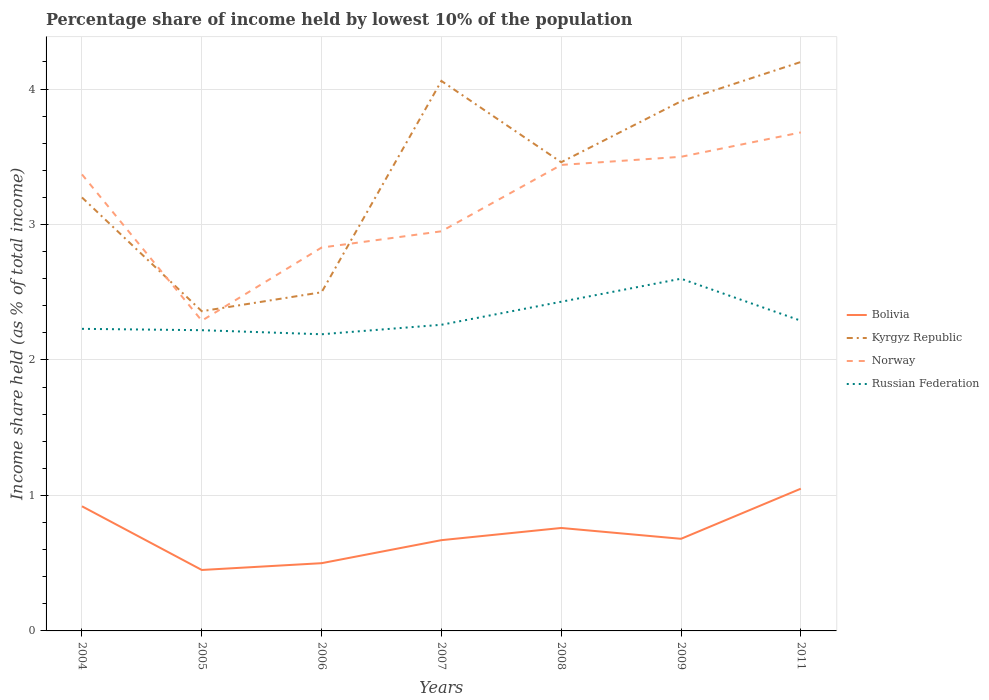How many different coloured lines are there?
Ensure brevity in your answer.  4. Does the line corresponding to Kyrgyz Republic intersect with the line corresponding to Bolivia?
Give a very brief answer. No. Is the number of lines equal to the number of legend labels?
Your response must be concise. Yes. Across all years, what is the maximum percentage share of income held by lowest 10% of the population in Norway?
Ensure brevity in your answer.  2.29. What is the total percentage share of income held by lowest 10% of the population in Norway in the graph?
Your answer should be very brief. -0.73. What is the difference between the highest and the second highest percentage share of income held by lowest 10% of the population in Norway?
Provide a short and direct response. 1.39. Is the percentage share of income held by lowest 10% of the population in Russian Federation strictly greater than the percentage share of income held by lowest 10% of the population in Kyrgyz Republic over the years?
Offer a terse response. Yes. How many lines are there?
Offer a terse response. 4. How many years are there in the graph?
Offer a very short reply. 7. Does the graph contain grids?
Offer a very short reply. Yes. How many legend labels are there?
Provide a succinct answer. 4. What is the title of the graph?
Offer a very short reply. Percentage share of income held by lowest 10% of the population. Does "Egypt, Arab Rep." appear as one of the legend labels in the graph?
Provide a short and direct response. No. What is the label or title of the Y-axis?
Offer a terse response. Income share held (as % of total income). What is the Income share held (as % of total income) of Bolivia in 2004?
Your response must be concise. 0.92. What is the Income share held (as % of total income) in Kyrgyz Republic in 2004?
Keep it short and to the point. 3.2. What is the Income share held (as % of total income) of Norway in 2004?
Provide a short and direct response. 3.37. What is the Income share held (as % of total income) in Russian Federation in 2004?
Provide a succinct answer. 2.23. What is the Income share held (as % of total income) of Bolivia in 2005?
Keep it short and to the point. 0.45. What is the Income share held (as % of total income) in Kyrgyz Republic in 2005?
Your answer should be very brief. 2.36. What is the Income share held (as % of total income) of Norway in 2005?
Keep it short and to the point. 2.29. What is the Income share held (as % of total income) of Russian Federation in 2005?
Your answer should be very brief. 2.22. What is the Income share held (as % of total income) of Norway in 2006?
Ensure brevity in your answer.  2.83. What is the Income share held (as % of total income) in Russian Federation in 2006?
Your response must be concise. 2.19. What is the Income share held (as % of total income) of Bolivia in 2007?
Your answer should be very brief. 0.67. What is the Income share held (as % of total income) of Kyrgyz Republic in 2007?
Give a very brief answer. 4.06. What is the Income share held (as % of total income) in Norway in 2007?
Give a very brief answer. 2.95. What is the Income share held (as % of total income) in Russian Federation in 2007?
Offer a terse response. 2.26. What is the Income share held (as % of total income) of Bolivia in 2008?
Provide a succinct answer. 0.76. What is the Income share held (as % of total income) in Kyrgyz Republic in 2008?
Offer a terse response. 3.46. What is the Income share held (as % of total income) of Norway in 2008?
Make the answer very short. 3.44. What is the Income share held (as % of total income) of Russian Federation in 2008?
Make the answer very short. 2.43. What is the Income share held (as % of total income) of Bolivia in 2009?
Provide a short and direct response. 0.68. What is the Income share held (as % of total income) in Kyrgyz Republic in 2009?
Offer a terse response. 3.91. What is the Income share held (as % of total income) of Norway in 2009?
Make the answer very short. 3.5. What is the Income share held (as % of total income) in Bolivia in 2011?
Provide a succinct answer. 1.05. What is the Income share held (as % of total income) in Norway in 2011?
Provide a short and direct response. 3.68. What is the Income share held (as % of total income) of Russian Federation in 2011?
Keep it short and to the point. 2.29. Across all years, what is the maximum Income share held (as % of total income) in Bolivia?
Offer a terse response. 1.05. Across all years, what is the maximum Income share held (as % of total income) in Kyrgyz Republic?
Offer a very short reply. 4.2. Across all years, what is the maximum Income share held (as % of total income) of Norway?
Your answer should be compact. 3.68. Across all years, what is the minimum Income share held (as % of total income) of Bolivia?
Offer a terse response. 0.45. Across all years, what is the minimum Income share held (as % of total income) of Kyrgyz Republic?
Ensure brevity in your answer.  2.36. Across all years, what is the minimum Income share held (as % of total income) in Norway?
Give a very brief answer. 2.29. Across all years, what is the minimum Income share held (as % of total income) of Russian Federation?
Provide a succinct answer. 2.19. What is the total Income share held (as % of total income) in Bolivia in the graph?
Your answer should be compact. 5.03. What is the total Income share held (as % of total income) in Kyrgyz Republic in the graph?
Your answer should be very brief. 23.69. What is the total Income share held (as % of total income) in Norway in the graph?
Provide a succinct answer. 22.06. What is the total Income share held (as % of total income) in Russian Federation in the graph?
Offer a terse response. 16.22. What is the difference between the Income share held (as % of total income) of Bolivia in 2004 and that in 2005?
Provide a short and direct response. 0.47. What is the difference between the Income share held (as % of total income) in Kyrgyz Republic in 2004 and that in 2005?
Provide a short and direct response. 0.84. What is the difference between the Income share held (as % of total income) of Russian Federation in 2004 and that in 2005?
Provide a short and direct response. 0.01. What is the difference between the Income share held (as % of total income) in Bolivia in 2004 and that in 2006?
Your answer should be compact. 0.42. What is the difference between the Income share held (as % of total income) in Norway in 2004 and that in 2006?
Offer a terse response. 0.54. What is the difference between the Income share held (as % of total income) in Russian Federation in 2004 and that in 2006?
Offer a very short reply. 0.04. What is the difference between the Income share held (as % of total income) of Bolivia in 2004 and that in 2007?
Offer a very short reply. 0.25. What is the difference between the Income share held (as % of total income) of Kyrgyz Republic in 2004 and that in 2007?
Make the answer very short. -0.86. What is the difference between the Income share held (as % of total income) in Norway in 2004 and that in 2007?
Give a very brief answer. 0.42. What is the difference between the Income share held (as % of total income) of Russian Federation in 2004 and that in 2007?
Make the answer very short. -0.03. What is the difference between the Income share held (as % of total income) of Bolivia in 2004 and that in 2008?
Make the answer very short. 0.16. What is the difference between the Income share held (as % of total income) of Kyrgyz Republic in 2004 and that in 2008?
Your answer should be compact. -0.26. What is the difference between the Income share held (as % of total income) in Norway in 2004 and that in 2008?
Your response must be concise. -0.07. What is the difference between the Income share held (as % of total income) in Russian Federation in 2004 and that in 2008?
Provide a succinct answer. -0.2. What is the difference between the Income share held (as % of total income) in Bolivia in 2004 and that in 2009?
Keep it short and to the point. 0.24. What is the difference between the Income share held (as % of total income) of Kyrgyz Republic in 2004 and that in 2009?
Your response must be concise. -0.71. What is the difference between the Income share held (as % of total income) of Norway in 2004 and that in 2009?
Make the answer very short. -0.13. What is the difference between the Income share held (as % of total income) of Russian Federation in 2004 and that in 2009?
Offer a terse response. -0.37. What is the difference between the Income share held (as % of total income) in Bolivia in 2004 and that in 2011?
Make the answer very short. -0.13. What is the difference between the Income share held (as % of total income) of Norway in 2004 and that in 2011?
Your answer should be compact. -0.31. What is the difference between the Income share held (as % of total income) in Russian Federation in 2004 and that in 2011?
Your response must be concise. -0.06. What is the difference between the Income share held (as % of total income) in Bolivia in 2005 and that in 2006?
Ensure brevity in your answer.  -0.05. What is the difference between the Income share held (as % of total income) in Kyrgyz Republic in 2005 and that in 2006?
Offer a terse response. -0.14. What is the difference between the Income share held (as % of total income) in Norway in 2005 and that in 2006?
Give a very brief answer. -0.54. What is the difference between the Income share held (as % of total income) in Russian Federation in 2005 and that in 2006?
Give a very brief answer. 0.03. What is the difference between the Income share held (as % of total income) in Bolivia in 2005 and that in 2007?
Keep it short and to the point. -0.22. What is the difference between the Income share held (as % of total income) in Kyrgyz Republic in 2005 and that in 2007?
Ensure brevity in your answer.  -1.7. What is the difference between the Income share held (as % of total income) of Norway in 2005 and that in 2007?
Ensure brevity in your answer.  -0.66. What is the difference between the Income share held (as % of total income) in Russian Federation in 2005 and that in 2007?
Offer a terse response. -0.04. What is the difference between the Income share held (as % of total income) in Bolivia in 2005 and that in 2008?
Your response must be concise. -0.31. What is the difference between the Income share held (as % of total income) of Norway in 2005 and that in 2008?
Your answer should be compact. -1.15. What is the difference between the Income share held (as % of total income) in Russian Federation in 2005 and that in 2008?
Give a very brief answer. -0.21. What is the difference between the Income share held (as % of total income) of Bolivia in 2005 and that in 2009?
Give a very brief answer. -0.23. What is the difference between the Income share held (as % of total income) in Kyrgyz Republic in 2005 and that in 2009?
Make the answer very short. -1.55. What is the difference between the Income share held (as % of total income) of Norway in 2005 and that in 2009?
Provide a succinct answer. -1.21. What is the difference between the Income share held (as % of total income) in Russian Federation in 2005 and that in 2009?
Ensure brevity in your answer.  -0.38. What is the difference between the Income share held (as % of total income) of Kyrgyz Republic in 2005 and that in 2011?
Make the answer very short. -1.84. What is the difference between the Income share held (as % of total income) of Norway in 2005 and that in 2011?
Provide a short and direct response. -1.39. What is the difference between the Income share held (as % of total income) in Russian Federation in 2005 and that in 2011?
Your response must be concise. -0.07. What is the difference between the Income share held (as % of total income) in Bolivia in 2006 and that in 2007?
Provide a succinct answer. -0.17. What is the difference between the Income share held (as % of total income) in Kyrgyz Republic in 2006 and that in 2007?
Provide a short and direct response. -1.56. What is the difference between the Income share held (as % of total income) of Norway in 2006 and that in 2007?
Give a very brief answer. -0.12. What is the difference between the Income share held (as % of total income) of Russian Federation in 2006 and that in 2007?
Keep it short and to the point. -0.07. What is the difference between the Income share held (as % of total income) of Bolivia in 2006 and that in 2008?
Give a very brief answer. -0.26. What is the difference between the Income share held (as % of total income) in Kyrgyz Republic in 2006 and that in 2008?
Your answer should be very brief. -0.96. What is the difference between the Income share held (as % of total income) in Norway in 2006 and that in 2008?
Keep it short and to the point. -0.61. What is the difference between the Income share held (as % of total income) in Russian Federation in 2006 and that in 2008?
Your answer should be very brief. -0.24. What is the difference between the Income share held (as % of total income) of Bolivia in 2006 and that in 2009?
Ensure brevity in your answer.  -0.18. What is the difference between the Income share held (as % of total income) of Kyrgyz Republic in 2006 and that in 2009?
Your response must be concise. -1.41. What is the difference between the Income share held (as % of total income) in Norway in 2006 and that in 2009?
Ensure brevity in your answer.  -0.67. What is the difference between the Income share held (as % of total income) in Russian Federation in 2006 and that in 2009?
Give a very brief answer. -0.41. What is the difference between the Income share held (as % of total income) in Bolivia in 2006 and that in 2011?
Keep it short and to the point. -0.55. What is the difference between the Income share held (as % of total income) in Kyrgyz Republic in 2006 and that in 2011?
Provide a short and direct response. -1.7. What is the difference between the Income share held (as % of total income) of Norway in 2006 and that in 2011?
Offer a terse response. -0.85. What is the difference between the Income share held (as % of total income) in Russian Federation in 2006 and that in 2011?
Provide a short and direct response. -0.1. What is the difference between the Income share held (as % of total income) of Bolivia in 2007 and that in 2008?
Make the answer very short. -0.09. What is the difference between the Income share held (as % of total income) in Norway in 2007 and that in 2008?
Provide a short and direct response. -0.49. What is the difference between the Income share held (as % of total income) of Russian Federation in 2007 and that in 2008?
Ensure brevity in your answer.  -0.17. What is the difference between the Income share held (as % of total income) of Bolivia in 2007 and that in 2009?
Your response must be concise. -0.01. What is the difference between the Income share held (as % of total income) in Kyrgyz Republic in 2007 and that in 2009?
Provide a succinct answer. 0.15. What is the difference between the Income share held (as % of total income) of Norway in 2007 and that in 2009?
Offer a terse response. -0.55. What is the difference between the Income share held (as % of total income) of Russian Federation in 2007 and that in 2009?
Provide a succinct answer. -0.34. What is the difference between the Income share held (as % of total income) in Bolivia in 2007 and that in 2011?
Your answer should be compact. -0.38. What is the difference between the Income share held (as % of total income) of Kyrgyz Republic in 2007 and that in 2011?
Provide a succinct answer. -0.14. What is the difference between the Income share held (as % of total income) of Norway in 2007 and that in 2011?
Your response must be concise. -0.73. What is the difference between the Income share held (as % of total income) in Russian Federation in 2007 and that in 2011?
Offer a terse response. -0.03. What is the difference between the Income share held (as % of total income) in Bolivia in 2008 and that in 2009?
Your answer should be very brief. 0.08. What is the difference between the Income share held (as % of total income) in Kyrgyz Republic in 2008 and that in 2009?
Provide a succinct answer. -0.45. What is the difference between the Income share held (as % of total income) of Norway in 2008 and that in 2009?
Keep it short and to the point. -0.06. What is the difference between the Income share held (as % of total income) of Russian Federation in 2008 and that in 2009?
Offer a very short reply. -0.17. What is the difference between the Income share held (as % of total income) of Bolivia in 2008 and that in 2011?
Your answer should be very brief. -0.29. What is the difference between the Income share held (as % of total income) of Kyrgyz Republic in 2008 and that in 2011?
Your response must be concise. -0.74. What is the difference between the Income share held (as % of total income) of Norway in 2008 and that in 2011?
Your response must be concise. -0.24. What is the difference between the Income share held (as % of total income) of Russian Federation in 2008 and that in 2011?
Offer a terse response. 0.14. What is the difference between the Income share held (as % of total income) of Bolivia in 2009 and that in 2011?
Your answer should be compact. -0.37. What is the difference between the Income share held (as % of total income) of Kyrgyz Republic in 2009 and that in 2011?
Offer a very short reply. -0.29. What is the difference between the Income share held (as % of total income) in Norway in 2009 and that in 2011?
Offer a very short reply. -0.18. What is the difference between the Income share held (as % of total income) in Russian Federation in 2009 and that in 2011?
Give a very brief answer. 0.31. What is the difference between the Income share held (as % of total income) in Bolivia in 2004 and the Income share held (as % of total income) in Kyrgyz Republic in 2005?
Offer a very short reply. -1.44. What is the difference between the Income share held (as % of total income) of Bolivia in 2004 and the Income share held (as % of total income) of Norway in 2005?
Your response must be concise. -1.37. What is the difference between the Income share held (as % of total income) of Kyrgyz Republic in 2004 and the Income share held (as % of total income) of Norway in 2005?
Your response must be concise. 0.91. What is the difference between the Income share held (as % of total income) of Norway in 2004 and the Income share held (as % of total income) of Russian Federation in 2005?
Your answer should be compact. 1.15. What is the difference between the Income share held (as % of total income) of Bolivia in 2004 and the Income share held (as % of total income) of Kyrgyz Republic in 2006?
Provide a succinct answer. -1.58. What is the difference between the Income share held (as % of total income) in Bolivia in 2004 and the Income share held (as % of total income) in Norway in 2006?
Make the answer very short. -1.91. What is the difference between the Income share held (as % of total income) of Bolivia in 2004 and the Income share held (as % of total income) of Russian Federation in 2006?
Your response must be concise. -1.27. What is the difference between the Income share held (as % of total income) in Kyrgyz Republic in 2004 and the Income share held (as % of total income) in Norway in 2006?
Keep it short and to the point. 0.37. What is the difference between the Income share held (as % of total income) of Norway in 2004 and the Income share held (as % of total income) of Russian Federation in 2006?
Keep it short and to the point. 1.18. What is the difference between the Income share held (as % of total income) of Bolivia in 2004 and the Income share held (as % of total income) of Kyrgyz Republic in 2007?
Ensure brevity in your answer.  -3.14. What is the difference between the Income share held (as % of total income) of Bolivia in 2004 and the Income share held (as % of total income) of Norway in 2007?
Your answer should be very brief. -2.03. What is the difference between the Income share held (as % of total income) in Bolivia in 2004 and the Income share held (as % of total income) in Russian Federation in 2007?
Offer a very short reply. -1.34. What is the difference between the Income share held (as % of total income) in Kyrgyz Republic in 2004 and the Income share held (as % of total income) in Norway in 2007?
Your answer should be compact. 0.25. What is the difference between the Income share held (as % of total income) in Kyrgyz Republic in 2004 and the Income share held (as % of total income) in Russian Federation in 2007?
Your response must be concise. 0.94. What is the difference between the Income share held (as % of total income) of Norway in 2004 and the Income share held (as % of total income) of Russian Federation in 2007?
Offer a terse response. 1.11. What is the difference between the Income share held (as % of total income) of Bolivia in 2004 and the Income share held (as % of total income) of Kyrgyz Republic in 2008?
Offer a very short reply. -2.54. What is the difference between the Income share held (as % of total income) in Bolivia in 2004 and the Income share held (as % of total income) in Norway in 2008?
Give a very brief answer. -2.52. What is the difference between the Income share held (as % of total income) in Bolivia in 2004 and the Income share held (as % of total income) in Russian Federation in 2008?
Ensure brevity in your answer.  -1.51. What is the difference between the Income share held (as % of total income) of Kyrgyz Republic in 2004 and the Income share held (as % of total income) of Norway in 2008?
Keep it short and to the point. -0.24. What is the difference between the Income share held (as % of total income) in Kyrgyz Republic in 2004 and the Income share held (as % of total income) in Russian Federation in 2008?
Ensure brevity in your answer.  0.77. What is the difference between the Income share held (as % of total income) in Bolivia in 2004 and the Income share held (as % of total income) in Kyrgyz Republic in 2009?
Your answer should be compact. -2.99. What is the difference between the Income share held (as % of total income) in Bolivia in 2004 and the Income share held (as % of total income) in Norway in 2009?
Make the answer very short. -2.58. What is the difference between the Income share held (as % of total income) in Bolivia in 2004 and the Income share held (as % of total income) in Russian Federation in 2009?
Your response must be concise. -1.68. What is the difference between the Income share held (as % of total income) in Kyrgyz Republic in 2004 and the Income share held (as % of total income) in Norway in 2009?
Keep it short and to the point. -0.3. What is the difference between the Income share held (as % of total income) in Norway in 2004 and the Income share held (as % of total income) in Russian Federation in 2009?
Ensure brevity in your answer.  0.77. What is the difference between the Income share held (as % of total income) in Bolivia in 2004 and the Income share held (as % of total income) in Kyrgyz Republic in 2011?
Keep it short and to the point. -3.28. What is the difference between the Income share held (as % of total income) of Bolivia in 2004 and the Income share held (as % of total income) of Norway in 2011?
Your answer should be compact. -2.76. What is the difference between the Income share held (as % of total income) of Bolivia in 2004 and the Income share held (as % of total income) of Russian Federation in 2011?
Your response must be concise. -1.37. What is the difference between the Income share held (as % of total income) of Kyrgyz Republic in 2004 and the Income share held (as % of total income) of Norway in 2011?
Your answer should be very brief. -0.48. What is the difference between the Income share held (as % of total income) in Kyrgyz Republic in 2004 and the Income share held (as % of total income) in Russian Federation in 2011?
Provide a short and direct response. 0.91. What is the difference between the Income share held (as % of total income) in Bolivia in 2005 and the Income share held (as % of total income) in Kyrgyz Republic in 2006?
Make the answer very short. -2.05. What is the difference between the Income share held (as % of total income) of Bolivia in 2005 and the Income share held (as % of total income) of Norway in 2006?
Provide a short and direct response. -2.38. What is the difference between the Income share held (as % of total income) in Bolivia in 2005 and the Income share held (as % of total income) in Russian Federation in 2006?
Provide a short and direct response. -1.74. What is the difference between the Income share held (as % of total income) in Kyrgyz Republic in 2005 and the Income share held (as % of total income) in Norway in 2006?
Provide a succinct answer. -0.47. What is the difference between the Income share held (as % of total income) in Kyrgyz Republic in 2005 and the Income share held (as % of total income) in Russian Federation in 2006?
Give a very brief answer. 0.17. What is the difference between the Income share held (as % of total income) of Norway in 2005 and the Income share held (as % of total income) of Russian Federation in 2006?
Provide a succinct answer. 0.1. What is the difference between the Income share held (as % of total income) in Bolivia in 2005 and the Income share held (as % of total income) in Kyrgyz Republic in 2007?
Give a very brief answer. -3.61. What is the difference between the Income share held (as % of total income) in Bolivia in 2005 and the Income share held (as % of total income) in Norway in 2007?
Ensure brevity in your answer.  -2.5. What is the difference between the Income share held (as % of total income) of Bolivia in 2005 and the Income share held (as % of total income) of Russian Federation in 2007?
Provide a short and direct response. -1.81. What is the difference between the Income share held (as % of total income) in Kyrgyz Republic in 2005 and the Income share held (as % of total income) in Norway in 2007?
Provide a short and direct response. -0.59. What is the difference between the Income share held (as % of total income) of Bolivia in 2005 and the Income share held (as % of total income) of Kyrgyz Republic in 2008?
Keep it short and to the point. -3.01. What is the difference between the Income share held (as % of total income) of Bolivia in 2005 and the Income share held (as % of total income) of Norway in 2008?
Make the answer very short. -2.99. What is the difference between the Income share held (as % of total income) of Bolivia in 2005 and the Income share held (as % of total income) of Russian Federation in 2008?
Your answer should be compact. -1.98. What is the difference between the Income share held (as % of total income) in Kyrgyz Republic in 2005 and the Income share held (as % of total income) in Norway in 2008?
Keep it short and to the point. -1.08. What is the difference between the Income share held (as % of total income) in Kyrgyz Republic in 2005 and the Income share held (as % of total income) in Russian Federation in 2008?
Give a very brief answer. -0.07. What is the difference between the Income share held (as % of total income) of Norway in 2005 and the Income share held (as % of total income) of Russian Federation in 2008?
Your answer should be compact. -0.14. What is the difference between the Income share held (as % of total income) of Bolivia in 2005 and the Income share held (as % of total income) of Kyrgyz Republic in 2009?
Provide a succinct answer. -3.46. What is the difference between the Income share held (as % of total income) in Bolivia in 2005 and the Income share held (as % of total income) in Norway in 2009?
Give a very brief answer. -3.05. What is the difference between the Income share held (as % of total income) in Bolivia in 2005 and the Income share held (as % of total income) in Russian Federation in 2009?
Your answer should be compact. -2.15. What is the difference between the Income share held (as % of total income) of Kyrgyz Republic in 2005 and the Income share held (as % of total income) of Norway in 2009?
Make the answer very short. -1.14. What is the difference between the Income share held (as % of total income) in Kyrgyz Republic in 2005 and the Income share held (as % of total income) in Russian Federation in 2009?
Provide a short and direct response. -0.24. What is the difference between the Income share held (as % of total income) in Norway in 2005 and the Income share held (as % of total income) in Russian Federation in 2009?
Give a very brief answer. -0.31. What is the difference between the Income share held (as % of total income) in Bolivia in 2005 and the Income share held (as % of total income) in Kyrgyz Republic in 2011?
Provide a succinct answer. -3.75. What is the difference between the Income share held (as % of total income) of Bolivia in 2005 and the Income share held (as % of total income) of Norway in 2011?
Your answer should be very brief. -3.23. What is the difference between the Income share held (as % of total income) of Bolivia in 2005 and the Income share held (as % of total income) of Russian Federation in 2011?
Provide a short and direct response. -1.84. What is the difference between the Income share held (as % of total income) of Kyrgyz Republic in 2005 and the Income share held (as % of total income) of Norway in 2011?
Your answer should be compact. -1.32. What is the difference between the Income share held (as % of total income) in Kyrgyz Republic in 2005 and the Income share held (as % of total income) in Russian Federation in 2011?
Your response must be concise. 0.07. What is the difference between the Income share held (as % of total income) of Bolivia in 2006 and the Income share held (as % of total income) of Kyrgyz Republic in 2007?
Keep it short and to the point. -3.56. What is the difference between the Income share held (as % of total income) of Bolivia in 2006 and the Income share held (as % of total income) of Norway in 2007?
Make the answer very short. -2.45. What is the difference between the Income share held (as % of total income) of Bolivia in 2006 and the Income share held (as % of total income) of Russian Federation in 2007?
Offer a terse response. -1.76. What is the difference between the Income share held (as % of total income) in Kyrgyz Republic in 2006 and the Income share held (as % of total income) in Norway in 2007?
Make the answer very short. -0.45. What is the difference between the Income share held (as % of total income) of Kyrgyz Republic in 2006 and the Income share held (as % of total income) of Russian Federation in 2007?
Make the answer very short. 0.24. What is the difference between the Income share held (as % of total income) of Norway in 2006 and the Income share held (as % of total income) of Russian Federation in 2007?
Your response must be concise. 0.57. What is the difference between the Income share held (as % of total income) of Bolivia in 2006 and the Income share held (as % of total income) of Kyrgyz Republic in 2008?
Keep it short and to the point. -2.96. What is the difference between the Income share held (as % of total income) of Bolivia in 2006 and the Income share held (as % of total income) of Norway in 2008?
Provide a succinct answer. -2.94. What is the difference between the Income share held (as % of total income) of Bolivia in 2006 and the Income share held (as % of total income) of Russian Federation in 2008?
Your answer should be very brief. -1.93. What is the difference between the Income share held (as % of total income) in Kyrgyz Republic in 2006 and the Income share held (as % of total income) in Norway in 2008?
Give a very brief answer. -0.94. What is the difference between the Income share held (as % of total income) of Kyrgyz Republic in 2006 and the Income share held (as % of total income) of Russian Federation in 2008?
Give a very brief answer. 0.07. What is the difference between the Income share held (as % of total income) in Bolivia in 2006 and the Income share held (as % of total income) in Kyrgyz Republic in 2009?
Your answer should be compact. -3.41. What is the difference between the Income share held (as % of total income) of Bolivia in 2006 and the Income share held (as % of total income) of Norway in 2009?
Your answer should be compact. -3. What is the difference between the Income share held (as % of total income) in Kyrgyz Republic in 2006 and the Income share held (as % of total income) in Norway in 2009?
Offer a very short reply. -1. What is the difference between the Income share held (as % of total income) in Norway in 2006 and the Income share held (as % of total income) in Russian Federation in 2009?
Keep it short and to the point. 0.23. What is the difference between the Income share held (as % of total income) of Bolivia in 2006 and the Income share held (as % of total income) of Norway in 2011?
Ensure brevity in your answer.  -3.18. What is the difference between the Income share held (as % of total income) of Bolivia in 2006 and the Income share held (as % of total income) of Russian Federation in 2011?
Keep it short and to the point. -1.79. What is the difference between the Income share held (as % of total income) of Kyrgyz Republic in 2006 and the Income share held (as % of total income) of Norway in 2011?
Make the answer very short. -1.18. What is the difference between the Income share held (as % of total income) of Kyrgyz Republic in 2006 and the Income share held (as % of total income) of Russian Federation in 2011?
Your answer should be very brief. 0.21. What is the difference between the Income share held (as % of total income) in Norway in 2006 and the Income share held (as % of total income) in Russian Federation in 2011?
Your response must be concise. 0.54. What is the difference between the Income share held (as % of total income) of Bolivia in 2007 and the Income share held (as % of total income) of Kyrgyz Republic in 2008?
Your answer should be very brief. -2.79. What is the difference between the Income share held (as % of total income) in Bolivia in 2007 and the Income share held (as % of total income) in Norway in 2008?
Provide a short and direct response. -2.77. What is the difference between the Income share held (as % of total income) in Bolivia in 2007 and the Income share held (as % of total income) in Russian Federation in 2008?
Keep it short and to the point. -1.76. What is the difference between the Income share held (as % of total income) in Kyrgyz Republic in 2007 and the Income share held (as % of total income) in Norway in 2008?
Your response must be concise. 0.62. What is the difference between the Income share held (as % of total income) in Kyrgyz Republic in 2007 and the Income share held (as % of total income) in Russian Federation in 2008?
Ensure brevity in your answer.  1.63. What is the difference between the Income share held (as % of total income) of Norway in 2007 and the Income share held (as % of total income) of Russian Federation in 2008?
Give a very brief answer. 0.52. What is the difference between the Income share held (as % of total income) of Bolivia in 2007 and the Income share held (as % of total income) of Kyrgyz Republic in 2009?
Your answer should be compact. -3.24. What is the difference between the Income share held (as % of total income) in Bolivia in 2007 and the Income share held (as % of total income) in Norway in 2009?
Give a very brief answer. -2.83. What is the difference between the Income share held (as % of total income) of Bolivia in 2007 and the Income share held (as % of total income) of Russian Federation in 2009?
Make the answer very short. -1.93. What is the difference between the Income share held (as % of total income) in Kyrgyz Republic in 2007 and the Income share held (as % of total income) in Norway in 2009?
Ensure brevity in your answer.  0.56. What is the difference between the Income share held (as % of total income) in Kyrgyz Republic in 2007 and the Income share held (as % of total income) in Russian Federation in 2009?
Your response must be concise. 1.46. What is the difference between the Income share held (as % of total income) of Bolivia in 2007 and the Income share held (as % of total income) of Kyrgyz Republic in 2011?
Provide a short and direct response. -3.53. What is the difference between the Income share held (as % of total income) of Bolivia in 2007 and the Income share held (as % of total income) of Norway in 2011?
Provide a succinct answer. -3.01. What is the difference between the Income share held (as % of total income) in Bolivia in 2007 and the Income share held (as % of total income) in Russian Federation in 2011?
Your response must be concise. -1.62. What is the difference between the Income share held (as % of total income) of Kyrgyz Republic in 2007 and the Income share held (as % of total income) of Norway in 2011?
Provide a short and direct response. 0.38. What is the difference between the Income share held (as % of total income) of Kyrgyz Republic in 2007 and the Income share held (as % of total income) of Russian Federation in 2011?
Your answer should be compact. 1.77. What is the difference between the Income share held (as % of total income) of Norway in 2007 and the Income share held (as % of total income) of Russian Federation in 2011?
Your response must be concise. 0.66. What is the difference between the Income share held (as % of total income) in Bolivia in 2008 and the Income share held (as % of total income) in Kyrgyz Republic in 2009?
Give a very brief answer. -3.15. What is the difference between the Income share held (as % of total income) in Bolivia in 2008 and the Income share held (as % of total income) in Norway in 2009?
Provide a succinct answer. -2.74. What is the difference between the Income share held (as % of total income) in Bolivia in 2008 and the Income share held (as % of total income) in Russian Federation in 2009?
Ensure brevity in your answer.  -1.84. What is the difference between the Income share held (as % of total income) in Kyrgyz Republic in 2008 and the Income share held (as % of total income) in Norway in 2009?
Your response must be concise. -0.04. What is the difference between the Income share held (as % of total income) of Kyrgyz Republic in 2008 and the Income share held (as % of total income) of Russian Federation in 2009?
Provide a succinct answer. 0.86. What is the difference between the Income share held (as % of total income) in Norway in 2008 and the Income share held (as % of total income) in Russian Federation in 2009?
Ensure brevity in your answer.  0.84. What is the difference between the Income share held (as % of total income) of Bolivia in 2008 and the Income share held (as % of total income) of Kyrgyz Republic in 2011?
Your answer should be compact. -3.44. What is the difference between the Income share held (as % of total income) in Bolivia in 2008 and the Income share held (as % of total income) in Norway in 2011?
Make the answer very short. -2.92. What is the difference between the Income share held (as % of total income) of Bolivia in 2008 and the Income share held (as % of total income) of Russian Federation in 2011?
Provide a short and direct response. -1.53. What is the difference between the Income share held (as % of total income) in Kyrgyz Republic in 2008 and the Income share held (as % of total income) in Norway in 2011?
Your answer should be very brief. -0.22. What is the difference between the Income share held (as % of total income) in Kyrgyz Republic in 2008 and the Income share held (as % of total income) in Russian Federation in 2011?
Ensure brevity in your answer.  1.17. What is the difference between the Income share held (as % of total income) in Norway in 2008 and the Income share held (as % of total income) in Russian Federation in 2011?
Make the answer very short. 1.15. What is the difference between the Income share held (as % of total income) of Bolivia in 2009 and the Income share held (as % of total income) of Kyrgyz Republic in 2011?
Give a very brief answer. -3.52. What is the difference between the Income share held (as % of total income) of Bolivia in 2009 and the Income share held (as % of total income) of Russian Federation in 2011?
Ensure brevity in your answer.  -1.61. What is the difference between the Income share held (as % of total income) of Kyrgyz Republic in 2009 and the Income share held (as % of total income) of Norway in 2011?
Make the answer very short. 0.23. What is the difference between the Income share held (as % of total income) in Kyrgyz Republic in 2009 and the Income share held (as % of total income) in Russian Federation in 2011?
Give a very brief answer. 1.62. What is the difference between the Income share held (as % of total income) in Norway in 2009 and the Income share held (as % of total income) in Russian Federation in 2011?
Your answer should be very brief. 1.21. What is the average Income share held (as % of total income) in Bolivia per year?
Offer a very short reply. 0.72. What is the average Income share held (as % of total income) in Kyrgyz Republic per year?
Provide a succinct answer. 3.38. What is the average Income share held (as % of total income) of Norway per year?
Offer a very short reply. 3.15. What is the average Income share held (as % of total income) in Russian Federation per year?
Offer a terse response. 2.32. In the year 2004, what is the difference between the Income share held (as % of total income) of Bolivia and Income share held (as % of total income) of Kyrgyz Republic?
Keep it short and to the point. -2.28. In the year 2004, what is the difference between the Income share held (as % of total income) of Bolivia and Income share held (as % of total income) of Norway?
Ensure brevity in your answer.  -2.45. In the year 2004, what is the difference between the Income share held (as % of total income) in Bolivia and Income share held (as % of total income) in Russian Federation?
Offer a very short reply. -1.31. In the year 2004, what is the difference between the Income share held (as % of total income) in Kyrgyz Republic and Income share held (as % of total income) in Norway?
Offer a very short reply. -0.17. In the year 2004, what is the difference between the Income share held (as % of total income) in Kyrgyz Republic and Income share held (as % of total income) in Russian Federation?
Your response must be concise. 0.97. In the year 2004, what is the difference between the Income share held (as % of total income) of Norway and Income share held (as % of total income) of Russian Federation?
Make the answer very short. 1.14. In the year 2005, what is the difference between the Income share held (as % of total income) of Bolivia and Income share held (as % of total income) of Kyrgyz Republic?
Provide a succinct answer. -1.91. In the year 2005, what is the difference between the Income share held (as % of total income) in Bolivia and Income share held (as % of total income) in Norway?
Your answer should be very brief. -1.84. In the year 2005, what is the difference between the Income share held (as % of total income) of Bolivia and Income share held (as % of total income) of Russian Federation?
Offer a terse response. -1.77. In the year 2005, what is the difference between the Income share held (as % of total income) in Kyrgyz Republic and Income share held (as % of total income) in Norway?
Provide a succinct answer. 0.07. In the year 2005, what is the difference between the Income share held (as % of total income) in Kyrgyz Republic and Income share held (as % of total income) in Russian Federation?
Provide a succinct answer. 0.14. In the year 2005, what is the difference between the Income share held (as % of total income) in Norway and Income share held (as % of total income) in Russian Federation?
Give a very brief answer. 0.07. In the year 2006, what is the difference between the Income share held (as % of total income) in Bolivia and Income share held (as % of total income) in Norway?
Make the answer very short. -2.33. In the year 2006, what is the difference between the Income share held (as % of total income) of Bolivia and Income share held (as % of total income) of Russian Federation?
Make the answer very short. -1.69. In the year 2006, what is the difference between the Income share held (as % of total income) in Kyrgyz Republic and Income share held (as % of total income) in Norway?
Your response must be concise. -0.33. In the year 2006, what is the difference between the Income share held (as % of total income) in Kyrgyz Republic and Income share held (as % of total income) in Russian Federation?
Provide a short and direct response. 0.31. In the year 2006, what is the difference between the Income share held (as % of total income) in Norway and Income share held (as % of total income) in Russian Federation?
Give a very brief answer. 0.64. In the year 2007, what is the difference between the Income share held (as % of total income) of Bolivia and Income share held (as % of total income) of Kyrgyz Republic?
Your response must be concise. -3.39. In the year 2007, what is the difference between the Income share held (as % of total income) in Bolivia and Income share held (as % of total income) in Norway?
Offer a terse response. -2.28. In the year 2007, what is the difference between the Income share held (as % of total income) of Bolivia and Income share held (as % of total income) of Russian Federation?
Provide a succinct answer. -1.59. In the year 2007, what is the difference between the Income share held (as % of total income) in Kyrgyz Republic and Income share held (as % of total income) in Norway?
Provide a succinct answer. 1.11. In the year 2007, what is the difference between the Income share held (as % of total income) in Kyrgyz Republic and Income share held (as % of total income) in Russian Federation?
Your response must be concise. 1.8. In the year 2007, what is the difference between the Income share held (as % of total income) of Norway and Income share held (as % of total income) of Russian Federation?
Offer a very short reply. 0.69. In the year 2008, what is the difference between the Income share held (as % of total income) of Bolivia and Income share held (as % of total income) of Kyrgyz Republic?
Keep it short and to the point. -2.7. In the year 2008, what is the difference between the Income share held (as % of total income) of Bolivia and Income share held (as % of total income) of Norway?
Make the answer very short. -2.68. In the year 2008, what is the difference between the Income share held (as % of total income) in Bolivia and Income share held (as % of total income) in Russian Federation?
Keep it short and to the point. -1.67. In the year 2008, what is the difference between the Income share held (as % of total income) in Kyrgyz Republic and Income share held (as % of total income) in Russian Federation?
Provide a succinct answer. 1.03. In the year 2009, what is the difference between the Income share held (as % of total income) in Bolivia and Income share held (as % of total income) in Kyrgyz Republic?
Offer a terse response. -3.23. In the year 2009, what is the difference between the Income share held (as % of total income) in Bolivia and Income share held (as % of total income) in Norway?
Your answer should be very brief. -2.82. In the year 2009, what is the difference between the Income share held (as % of total income) of Bolivia and Income share held (as % of total income) of Russian Federation?
Provide a short and direct response. -1.92. In the year 2009, what is the difference between the Income share held (as % of total income) in Kyrgyz Republic and Income share held (as % of total income) in Norway?
Offer a terse response. 0.41. In the year 2009, what is the difference between the Income share held (as % of total income) in Kyrgyz Republic and Income share held (as % of total income) in Russian Federation?
Your answer should be very brief. 1.31. In the year 2011, what is the difference between the Income share held (as % of total income) of Bolivia and Income share held (as % of total income) of Kyrgyz Republic?
Give a very brief answer. -3.15. In the year 2011, what is the difference between the Income share held (as % of total income) of Bolivia and Income share held (as % of total income) of Norway?
Provide a succinct answer. -2.63. In the year 2011, what is the difference between the Income share held (as % of total income) of Bolivia and Income share held (as % of total income) of Russian Federation?
Offer a terse response. -1.24. In the year 2011, what is the difference between the Income share held (as % of total income) of Kyrgyz Republic and Income share held (as % of total income) of Norway?
Provide a short and direct response. 0.52. In the year 2011, what is the difference between the Income share held (as % of total income) of Kyrgyz Republic and Income share held (as % of total income) of Russian Federation?
Keep it short and to the point. 1.91. In the year 2011, what is the difference between the Income share held (as % of total income) in Norway and Income share held (as % of total income) in Russian Federation?
Your response must be concise. 1.39. What is the ratio of the Income share held (as % of total income) of Bolivia in 2004 to that in 2005?
Give a very brief answer. 2.04. What is the ratio of the Income share held (as % of total income) in Kyrgyz Republic in 2004 to that in 2005?
Give a very brief answer. 1.36. What is the ratio of the Income share held (as % of total income) in Norway in 2004 to that in 2005?
Give a very brief answer. 1.47. What is the ratio of the Income share held (as % of total income) in Russian Federation in 2004 to that in 2005?
Your answer should be very brief. 1. What is the ratio of the Income share held (as % of total income) in Bolivia in 2004 to that in 2006?
Provide a short and direct response. 1.84. What is the ratio of the Income share held (as % of total income) in Kyrgyz Republic in 2004 to that in 2006?
Your answer should be compact. 1.28. What is the ratio of the Income share held (as % of total income) of Norway in 2004 to that in 2006?
Keep it short and to the point. 1.19. What is the ratio of the Income share held (as % of total income) of Russian Federation in 2004 to that in 2006?
Offer a terse response. 1.02. What is the ratio of the Income share held (as % of total income) of Bolivia in 2004 to that in 2007?
Give a very brief answer. 1.37. What is the ratio of the Income share held (as % of total income) of Kyrgyz Republic in 2004 to that in 2007?
Your answer should be very brief. 0.79. What is the ratio of the Income share held (as % of total income) of Norway in 2004 to that in 2007?
Your response must be concise. 1.14. What is the ratio of the Income share held (as % of total income) of Russian Federation in 2004 to that in 2007?
Your answer should be very brief. 0.99. What is the ratio of the Income share held (as % of total income) of Bolivia in 2004 to that in 2008?
Offer a very short reply. 1.21. What is the ratio of the Income share held (as % of total income) in Kyrgyz Republic in 2004 to that in 2008?
Your answer should be compact. 0.92. What is the ratio of the Income share held (as % of total income) of Norway in 2004 to that in 2008?
Keep it short and to the point. 0.98. What is the ratio of the Income share held (as % of total income) of Russian Federation in 2004 to that in 2008?
Provide a succinct answer. 0.92. What is the ratio of the Income share held (as % of total income) in Bolivia in 2004 to that in 2009?
Make the answer very short. 1.35. What is the ratio of the Income share held (as % of total income) in Kyrgyz Republic in 2004 to that in 2009?
Offer a terse response. 0.82. What is the ratio of the Income share held (as % of total income) in Norway in 2004 to that in 2009?
Make the answer very short. 0.96. What is the ratio of the Income share held (as % of total income) in Russian Federation in 2004 to that in 2009?
Provide a succinct answer. 0.86. What is the ratio of the Income share held (as % of total income) in Bolivia in 2004 to that in 2011?
Keep it short and to the point. 0.88. What is the ratio of the Income share held (as % of total income) in Kyrgyz Republic in 2004 to that in 2011?
Give a very brief answer. 0.76. What is the ratio of the Income share held (as % of total income) of Norway in 2004 to that in 2011?
Make the answer very short. 0.92. What is the ratio of the Income share held (as % of total income) in Russian Federation in 2004 to that in 2011?
Offer a terse response. 0.97. What is the ratio of the Income share held (as % of total income) in Bolivia in 2005 to that in 2006?
Your answer should be compact. 0.9. What is the ratio of the Income share held (as % of total income) in Kyrgyz Republic in 2005 to that in 2006?
Give a very brief answer. 0.94. What is the ratio of the Income share held (as % of total income) of Norway in 2005 to that in 2006?
Your answer should be very brief. 0.81. What is the ratio of the Income share held (as % of total income) of Russian Federation in 2005 to that in 2006?
Provide a short and direct response. 1.01. What is the ratio of the Income share held (as % of total income) in Bolivia in 2005 to that in 2007?
Ensure brevity in your answer.  0.67. What is the ratio of the Income share held (as % of total income) in Kyrgyz Republic in 2005 to that in 2007?
Provide a short and direct response. 0.58. What is the ratio of the Income share held (as % of total income) of Norway in 2005 to that in 2007?
Offer a very short reply. 0.78. What is the ratio of the Income share held (as % of total income) of Russian Federation in 2005 to that in 2007?
Make the answer very short. 0.98. What is the ratio of the Income share held (as % of total income) in Bolivia in 2005 to that in 2008?
Keep it short and to the point. 0.59. What is the ratio of the Income share held (as % of total income) in Kyrgyz Republic in 2005 to that in 2008?
Provide a short and direct response. 0.68. What is the ratio of the Income share held (as % of total income) in Norway in 2005 to that in 2008?
Provide a short and direct response. 0.67. What is the ratio of the Income share held (as % of total income) of Russian Federation in 2005 to that in 2008?
Keep it short and to the point. 0.91. What is the ratio of the Income share held (as % of total income) of Bolivia in 2005 to that in 2009?
Your answer should be compact. 0.66. What is the ratio of the Income share held (as % of total income) in Kyrgyz Republic in 2005 to that in 2009?
Offer a very short reply. 0.6. What is the ratio of the Income share held (as % of total income) in Norway in 2005 to that in 2009?
Offer a terse response. 0.65. What is the ratio of the Income share held (as % of total income) of Russian Federation in 2005 to that in 2009?
Keep it short and to the point. 0.85. What is the ratio of the Income share held (as % of total income) in Bolivia in 2005 to that in 2011?
Offer a very short reply. 0.43. What is the ratio of the Income share held (as % of total income) of Kyrgyz Republic in 2005 to that in 2011?
Your response must be concise. 0.56. What is the ratio of the Income share held (as % of total income) of Norway in 2005 to that in 2011?
Provide a short and direct response. 0.62. What is the ratio of the Income share held (as % of total income) of Russian Federation in 2005 to that in 2011?
Ensure brevity in your answer.  0.97. What is the ratio of the Income share held (as % of total income) of Bolivia in 2006 to that in 2007?
Offer a terse response. 0.75. What is the ratio of the Income share held (as % of total income) in Kyrgyz Republic in 2006 to that in 2007?
Ensure brevity in your answer.  0.62. What is the ratio of the Income share held (as % of total income) in Norway in 2006 to that in 2007?
Ensure brevity in your answer.  0.96. What is the ratio of the Income share held (as % of total income) of Russian Federation in 2006 to that in 2007?
Offer a terse response. 0.97. What is the ratio of the Income share held (as % of total income) in Bolivia in 2006 to that in 2008?
Your answer should be compact. 0.66. What is the ratio of the Income share held (as % of total income) of Kyrgyz Republic in 2006 to that in 2008?
Your response must be concise. 0.72. What is the ratio of the Income share held (as % of total income) in Norway in 2006 to that in 2008?
Make the answer very short. 0.82. What is the ratio of the Income share held (as % of total income) of Russian Federation in 2006 to that in 2008?
Your response must be concise. 0.9. What is the ratio of the Income share held (as % of total income) of Bolivia in 2006 to that in 2009?
Ensure brevity in your answer.  0.74. What is the ratio of the Income share held (as % of total income) of Kyrgyz Republic in 2006 to that in 2009?
Your response must be concise. 0.64. What is the ratio of the Income share held (as % of total income) of Norway in 2006 to that in 2009?
Give a very brief answer. 0.81. What is the ratio of the Income share held (as % of total income) in Russian Federation in 2006 to that in 2009?
Provide a succinct answer. 0.84. What is the ratio of the Income share held (as % of total income) in Bolivia in 2006 to that in 2011?
Offer a very short reply. 0.48. What is the ratio of the Income share held (as % of total income) of Kyrgyz Republic in 2006 to that in 2011?
Make the answer very short. 0.6. What is the ratio of the Income share held (as % of total income) in Norway in 2006 to that in 2011?
Keep it short and to the point. 0.77. What is the ratio of the Income share held (as % of total income) of Russian Federation in 2006 to that in 2011?
Offer a very short reply. 0.96. What is the ratio of the Income share held (as % of total income) of Bolivia in 2007 to that in 2008?
Your answer should be very brief. 0.88. What is the ratio of the Income share held (as % of total income) in Kyrgyz Republic in 2007 to that in 2008?
Your answer should be compact. 1.17. What is the ratio of the Income share held (as % of total income) of Norway in 2007 to that in 2008?
Offer a terse response. 0.86. What is the ratio of the Income share held (as % of total income) in Kyrgyz Republic in 2007 to that in 2009?
Offer a terse response. 1.04. What is the ratio of the Income share held (as % of total income) of Norway in 2007 to that in 2009?
Offer a very short reply. 0.84. What is the ratio of the Income share held (as % of total income) of Russian Federation in 2007 to that in 2009?
Ensure brevity in your answer.  0.87. What is the ratio of the Income share held (as % of total income) of Bolivia in 2007 to that in 2011?
Give a very brief answer. 0.64. What is the ratio of the Income share held (as % of total income) in Kyrgyz Republic in 2007 to that in 2011?
Provide a short and direct response. 0.97. What is the ratio of the Income share held (as % of total income) in Norway in 2007 to that in 2011?
Keep it short and to the point. 0.8. What is the ratio of the Income share held (as % of total income) in Russian Federation in 2007 to that in 2011?
Your answer should be very brief. 0.99. What is the ratio of the Income share held (as % of total income) of Bolivia in 2008 to that in 2009?
Provide a short and direct response. 1.12. What is the ratio of the Income share held (as % of total income) in Kyrgyz Republic in 2008 to that in 2009?
Ensure brevity in your answer.  0.88. What is the ratio of the Income share held (as % of total income) of Norway in 2008 to that in 2009?
Ensure brevity in your answer.  0.98. What is the ratio of the Income share held (as % of total income) in Russian Federation in 2008 to that in 2009?
Offer a terse response. 0.93. What is the ratio of the Income share held (as % of total income) of Bolivia in 2008 to that in 2011?
Give a very brief answer. 0.72. What is the ratio of the Income share held (as % of total income) of Kyrgyz Republic in 2008 to that in 2011?
Keep it short and to the point. 0.82. What is the ratio of the Income share held (as % of total income) in Norway in 2008 to that in 2011?
Keep it short and to the point. 0.93. What is the ratio of the Income share held (as % of total income) of Russian Federation in 2008 to that in 2011?
Keep it short and to the point. 1.06. What is the ratio of the Income share held (as % of total income) in Bolivia in 2009 to that in 2011?
Offer a very short reply. 0.65. What is the ratio of the Income share held (as % of total income) in Norway in 2009 to that in 2011?
Offer a very short reply. 0.95. What is the ratio of the Income share held (as % of total income) in Russian Federation in 2009 to that in 2011?
Offer a very short reply. 1.14. What is the difference between the highest and the second highest Income share held (as % of total income) of Bolivia?
Provide a short and direct response. 0.13. What is the difference between the highest and the second highest Income share held (as % of total income) of Kyrgyz Republic?
Offer a terse response. 0.14. What is the difference between the highest and the second highest Income share held (as % of total income) of Norway?
Make the answer very short. 0.18. What is the difference between the highest and the second highest Income share held (as % of total income) of Russian Federation?
Offer a terse response. 0.17. What is the difference between the highest and the lowest Income share held (as % of total income) in Kyrgyz Republic?
Keep it short and to the point. 1.84. What is the difference between the highest and the lowest Income share held (as % of total income) in Norway?
Ensure brevity in your answer.  1.39. What is the difference between the highest and the lowest Income share held (as % of total income) in Russian Federation?
Keep it short and to the point. 0.41. 